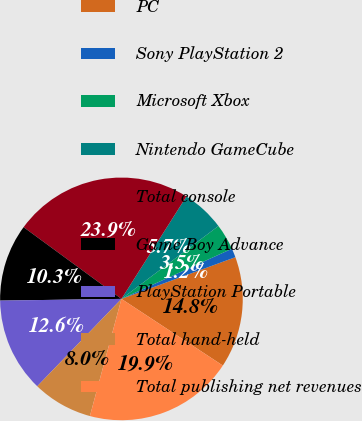Convert chart. <chart><loc_0><loc_0><loc_500><loc_500><pie_chart><fcel>PC<fcel>Sony PlayStation 2<fcel>Microsoft Xbox<fcel>Nintendo GameCube<fcel>Total console<fcel>Game Boy Advance<fcel>PlayStation Portable<fcel>Total hand-held<fcel>Total publishing net revenues<nl><fcel>14.84%<fcel>1.2%<fcel>3.47%<fcel>5.75%<fcel>23.93%<fcel>10.29%<fcel>12.57%<fcel>8.02%<fcel>19.93%<nl></chart> 